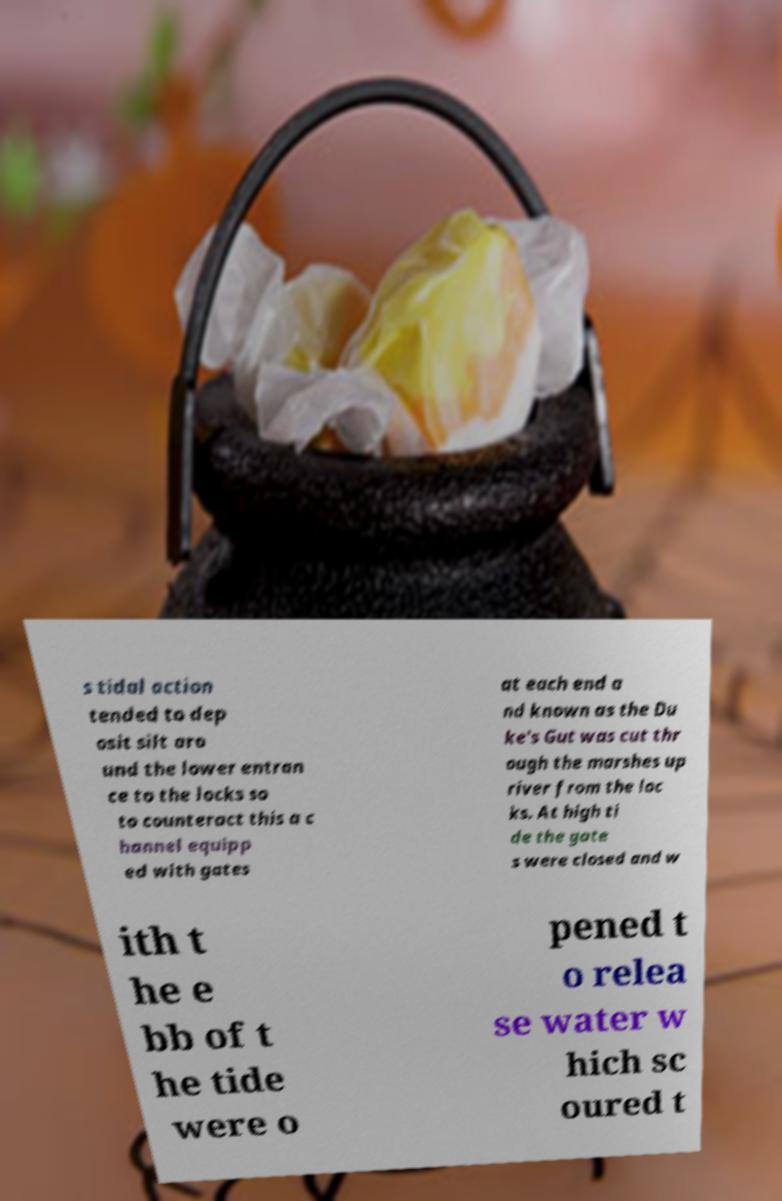Could you assist in decoding the text presented in this image and type it out clearly? s tidal action tended to dep osit silt aro und the lower entran ce to the locks so to counteract this a c hannel equipp ed with gates at each end a nd known as the Du ke's Gut was cut thr ough the marshes up river from the loc ks. At high ti de the gate s were closed and w ith t he e bb of t he tide were o pened t o relea se water w hich sc oured t 